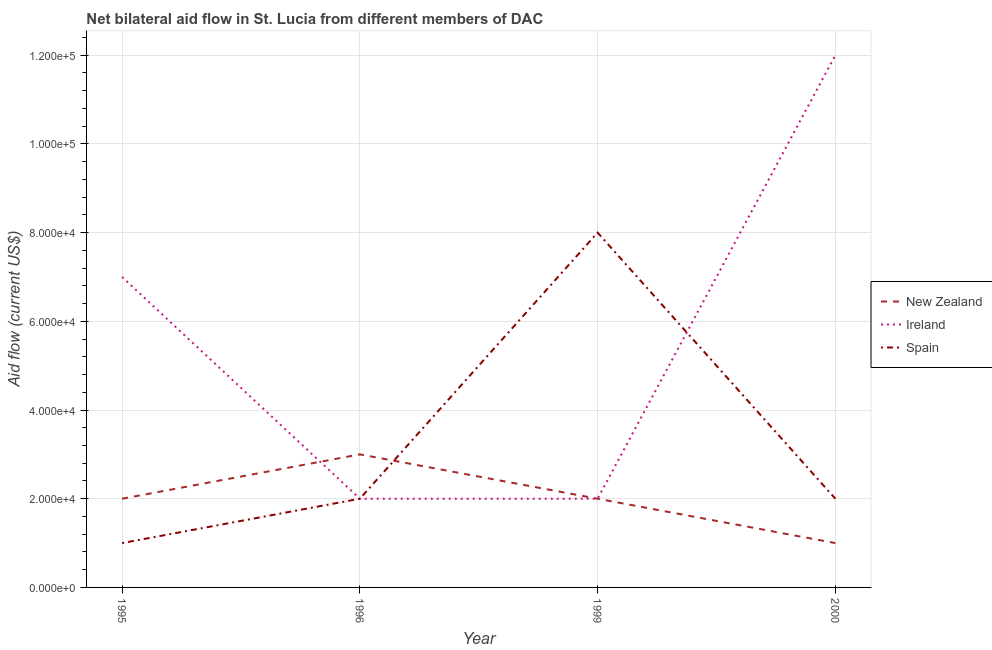Is the number of lines equal to the number of legend labels?
Make the answer very short. Yes. What is the amount of aid provided by spain in 1995?
Give a very brief answer. 10000. Across all years, what is the maximum amount of aid provided by ireland?
Provide a short and direct response. 1.20e+05. Across all years, what is the minimum amount of aid provided by spain?
Your response must be concise. 10000. In which year was the amount of aid provided by ireland minimum?
Your response must be concise. 1996. What is the total amount of aid provided by spain in the graph?
Your answer should be compact. 1.30e+05. What is the difference between the amount of aid provided by spain in 1995 and that in 1996?
Provide a short and direct response. -10000. What is the difference between the amount of aid provided by spain in 1999 and the amount of aid provided by ireland in 1996?
Keep it short and to the point. 6.00e+04. What is the average amount of aid provided by spain per year?
Provide a succinct answer. 3.25e+04. In the year 1996, what is the difference between the amount of aid provided by ireland and amount of aid provided by new zealand?
Keep it short and to the point. -10000. What is the ratio of the amount of aid provided by spain in 1999 to that in 2000?
Your answer should be very brief. 4. Is the amount of aid provided by spain in 1995 less than that in 1996?
Offer a terse response. Yes. What is the difference between the highest and the lowest amount of aid provided by ireland?
Offer a very short reply. 1.00e+05. Is the sum of the amount of aid provided by spain in 1995 and 2000 greater than the maximum amount of aid provided by ireland across all years?
Offer a terse response. No. Does the amount of aid provided by ireland monotonically increase over the years?
Offer a very short reply. No. How many lines are there?
Keep it short and to the point. 3. How many years are there in the graph?
Provide a short and direct response. 4. How many legend labels are there?
Your answer should be very brief. 3. How are the legend labels stacked?
Ensure brevity in your answer.  Vertical. What is the title of the graph?
Your response must be concise. Net bilateral aid flow in St. Lucia from different members of DAC. Does "Infant(male)" appear as one of the legend labels in the graph?
Your response must be concise. No. What is the label or title of the X-axis?
Your answer should be very brief. Year. What is the label or title of the Y-axis?
Your answer should be very brief. Aid flow (current US$). What is the Aid flow (current US$) of Spain in 1995?
Offer a terse response. 10000. What is the Aid flow (current US$) of New Zealand in 1999?
Make the answer very short. 2.00e+04. What is the Aid flow (current US$) of Spain in 1999?
Your answer should be compact. 8.00e+04. What is the Aid flow (current US$) in Spain in 2000?
Your answer should be very brief. 2.00e+04. Across all years, what is the maximum Aid flow (current US$) of Ireland?
Offer a very short reply. 1.20e+05. Across all years, what is the maximum Aid flow (current US$) of Spain?
Provide a short and direct response. 8.00e+04. Across all years, what is the minimum Aid flow (current US$) of New Zealand?
Keep it short and to the point. 10000. What is the total Aid flow (current US$) in New Zealand in the graph?
Make the answer very short. 8.00e+04. What is the difference between the Aid flow (current US$) of Spain in 1995 and that in 1999?
Your answer should be compact. -7.00e+04. What is the difference between the Aid flow (current US$) in Ireland in 1995 and that in 2000?
Your answer should be compact. -5.00e+04. What is the difference between the Aid flow (current US$) in Spain in 1995 and that in 2000?
Your answer should be compact. -10000. What is the difference between the Aid flow (current US$) in New Zealand in 1996 and that in 1999?
Keep it short and to the point. 10000. What is the difference between the Aid flow (current US$) of New Zealand in 1996 and that in 2000?
Make the answer very short. 2.00e+04. What is the difference between the Aid flow (current US$) of Ireland in 1996 and that in 2000?
Your answer should be compact. -1.00e+05. What is the difference between the Aid flow (current US$) in Spain in 1999 and that in 2000?
Keep it short and to the point. 6.00e+04. What is the difference between the Aid flow (current US$) of Ireland in 1995 and the Aid flow (current US$) of Spain in 1996?
Offer a terse response. 5.00e+04. What is the difference between the Aid flow (current US$) in Ireland in 1995 and the Aid flow (current US$) in Spain in 1999?
Keep it short and to the point. -10000. What is the difference between the Aid flow (current US$) of New Zealand in 1995 and the Aid flow (current US$) of Ireland in 2000?
Your answer should be very brief. -1.00e+05. What is the difference between the Aid flow (current US$) in New Zealand in 1996 and the Aid flow (current US$) in Ireland in 1999?
Give a very brief answer. 10000. What is the difference between the Aid flow (current US$) of Ireland in 1996 and the Aid flow (current US$) of Spain in 1999?
Your answer should be compact. -6.00e+04. What is the difference between the Aid flow (current US$) in Ireland in 1996 and the Aid flow (current US$) in Spain in 2000?
Ensure brevity in your answer.  0. What is the difference between the Aid flow (current US$) in New Zealand in 1999 and the Aid flow (current US$) in Ireland in 2000?
Provide a succinct answer. -1.00e+05. What is the difference between the Aid flow (current US$) in New Zealand in 1999 and the Aid flow (current US$) in Spain in 2000?
Provide a succinct answer. 0. What is the difference between the Aid flow (current US$) of Ireland in 1999 and the Aid flow (current US$) of Spain in 2000?
Provide a short and direct response. 0. What is the average Aid flow (current US$) in Ireland per year?
Give a very brief answer. 5.75e+04. What is the average Aid flow (current US$) in Spain per year?
Offer a very short reply. 3.25e+04. In the year 1995, what is the difference between the Aid flow (current US$) of New Zealand and Aid flow (current US$) of Spain?
Offer a very short reply. 10000. In the year 1996, what is the difference between the Aid flow (current US$) in New Zealand and Aid flow (current US$) in Ireland?
Your response must be concise. 10000. In the year 1996, what is the difference between the Aid flow (current US$) in Ireland and Aid flow (current US$) in Spain?
Give a very brief answer. 0. In the year 1999, what is the difference between the Aid flow (current US$) of New Zealand and Aid flow (current US$) of Spain?
Offer a very short reply. -6.00e+04. In the year 2000, what is the difference between the Aid flow (current US$) in Ireland and Aid flow (current US$) in Spain?
Keep it short and to the point. 1.00e+05. What is the ratio of the Aid flow (current US$) of New Zealand in 1995 to that in 1996?
Give a very brief answer. 0.67. What is the ratio of the Aid flow (current US$) of Spain in 1995 to that in 1996?
Ensure brevity in your answer.  0.5. What is the ratio of the Aid flow (current US$) in New Zealand in 1995 to that in 2000?
Keep it short and to the point. 2. What is the ratio of the Aid flow (current US$) in Ireland in 1995 to that in 2000?
Your response must be concise. 0.58. What is the ratio of the Aid flow (current US$) in Spain in 1996 to that in 1999?
Provide a succinct answer. 0.25. What is the ratio of the Aid flow (current US$) in Spain in 1996 to that in 2000?
Give a very brief answer. 1. What is the ratio of the Aid flow (current US$) in New Zealand in 1999 to that in 2000?
Your answer should be compact. 2. What is the ratio of the Aid flow (current US$) in Ireland in 1999 to that in 2000?
Offer a terse response. 0.17. What is the difference between the highest and the lowest Aid flow (current US$) of New Zealand?
Offer a very short reply. 2.00e+04. What is the difference between the highest and the lowest Aid flow (current US$) in Spain?
Offer a very short reply. 7.00e+04. 